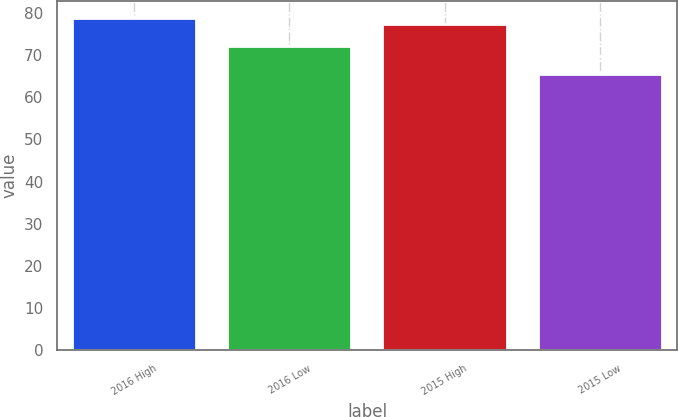<chart> <loc_0><loc_0><loc_500><loc_500><bar_chart><fcel>2016 High<fcel>2016 Low<fcel>2015 High<fcel>2015 Low<nl><fcel>78.92<fcel>72.28<fcel>77.39<fcel>65.51<nl></chart> 